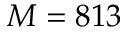<formula> <loc_0><loc_0><loc_500><loc_500>M = 8 1 3</formula> 